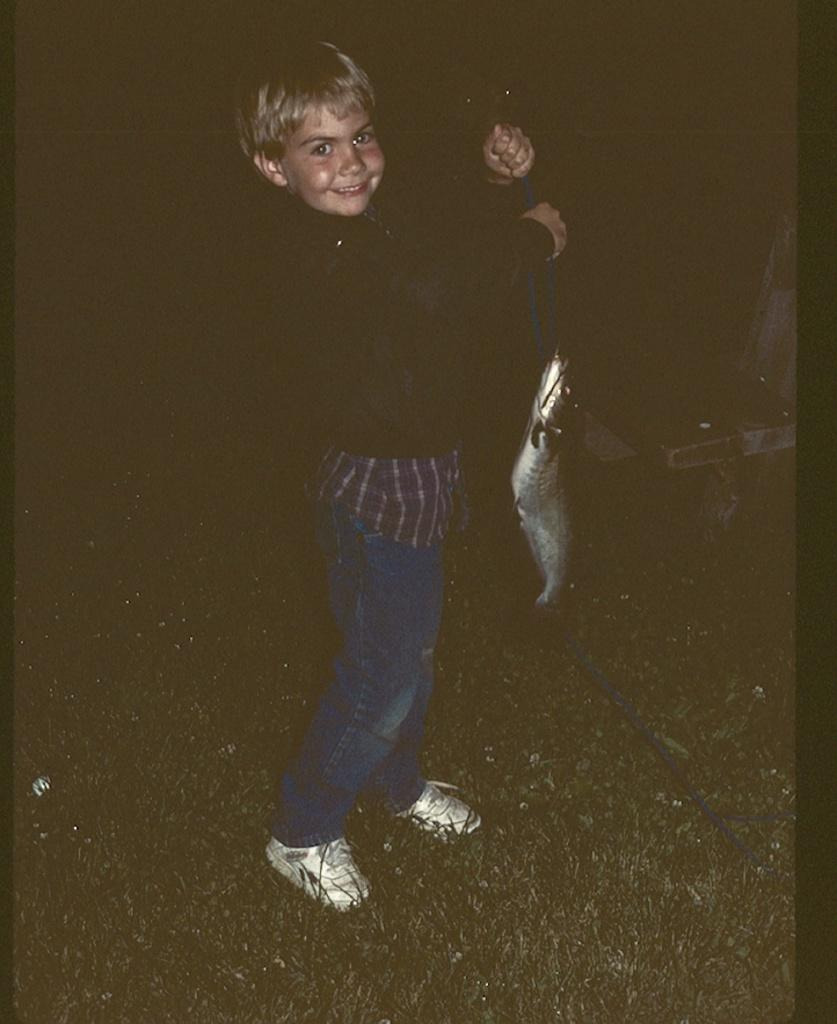Who is present in the image? There is a boy in the image. What is the boy doing in the image? The boy is standing on the ground and holding a rope in his hands. What is the rope connected to? The rope is connected to a fish. What can be seen in the background of the image? There is an object visible in the background of the image. What type of zephyr is blowing through the boy's hair in the image? There is no zephyr present in the image; it is a still image with no indication of wind or breeze. 